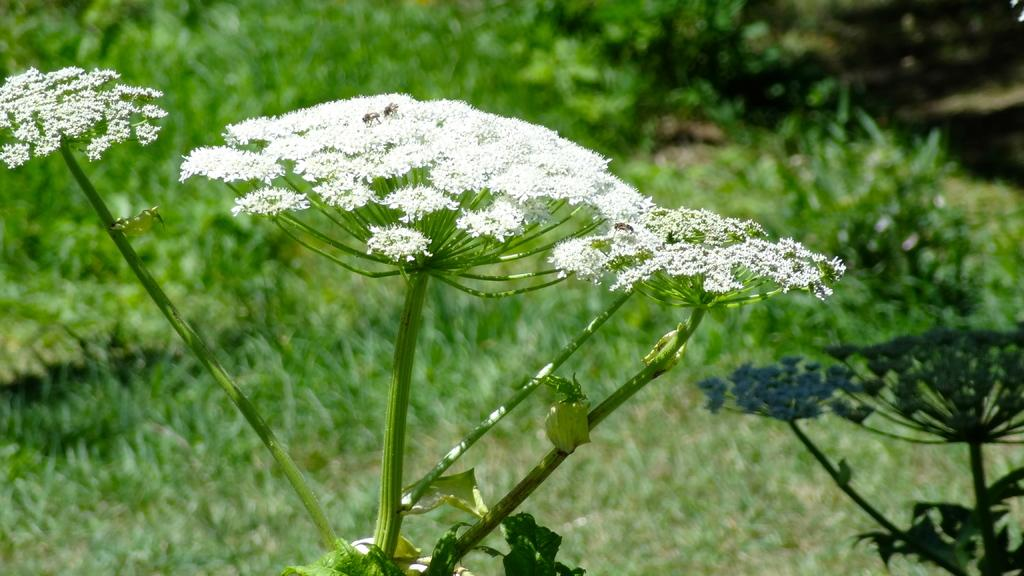What type of plants can be seen in the image? There are flower plants in the image. What color are the flowers on the plants? The flowers are white in color. Can you describe the background of the image? The background of the image is blurred. How does the person in the image kick the door open? There is no person or door present in the image; it only features flower plants with white flowers and a blurred background. 